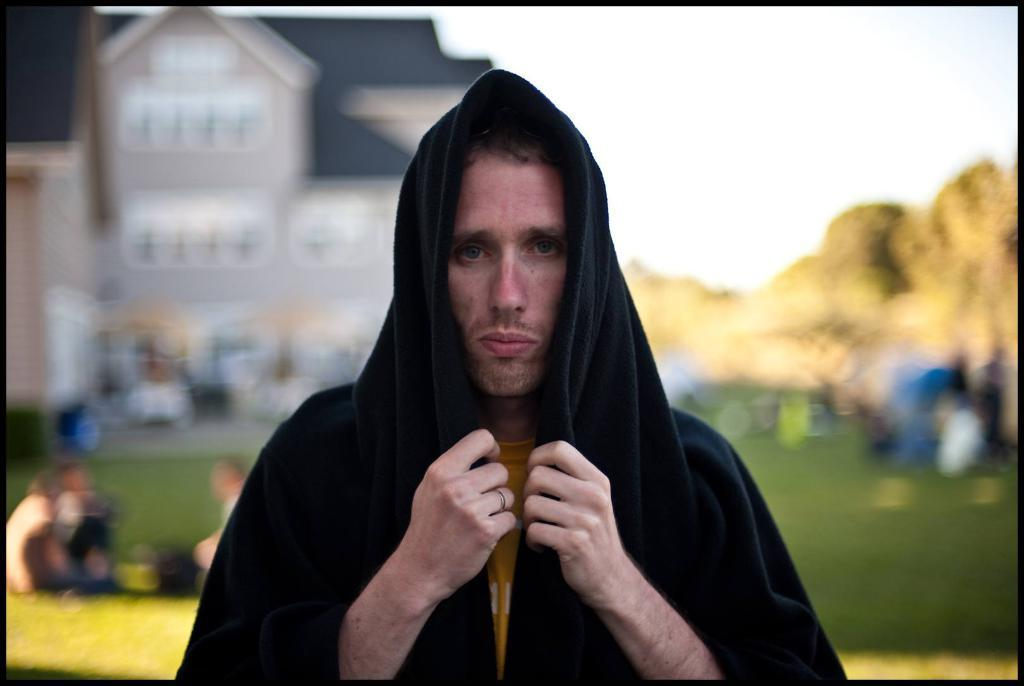What is the main subject of the image? There is a person in the image. What is the person wearing? The person is wearing a black dress. What can be seen in the background of the image? There are buildings and people in the background of the image. What is the color of the sky in the image? The sky is visible in the image, and it appears to be white. How does the person use their hair to communicate with the buildings in the image? The person's hair is not mentioned in the image, and there is no indication that it is being used to communicate with the buildings. 